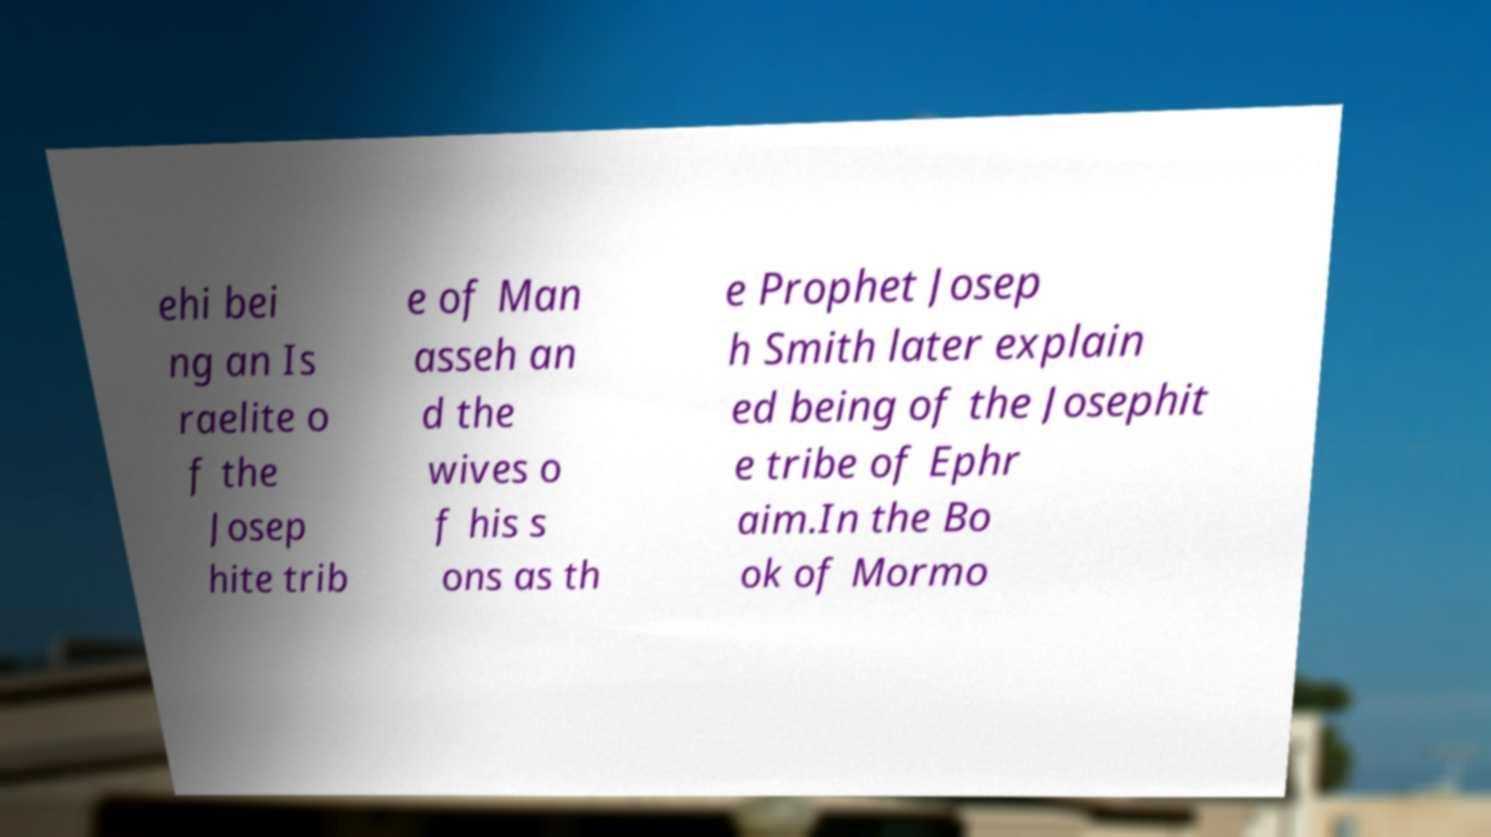Please identify and transcribe the text found in this image. ehi bei ng an Is raelite o f the Josep hite trib e of Man asseh an d the wives o f his s ons as th e Prophet Josep h Smith later explain ed being of the Josephit e tribe of Ephr aim.In the Bo ok of Mormo 